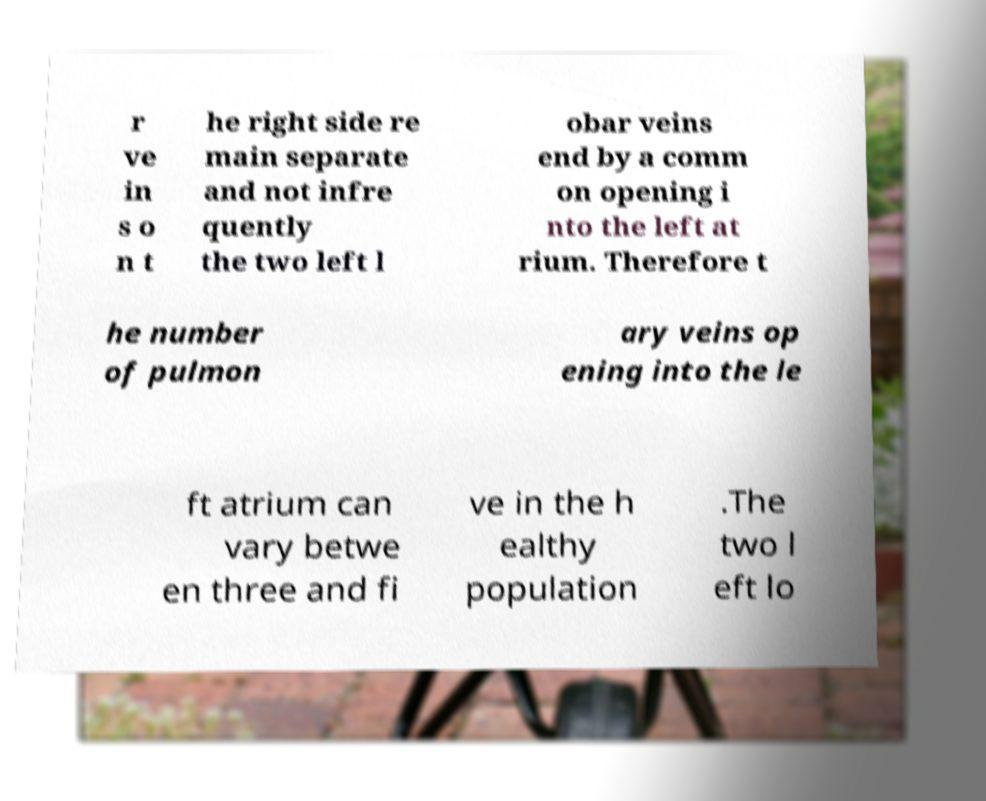Could you extract and type out the text from this image? r ve in s o n t he right side re main separate and not infre quently the two left l obar veins end by a comm on opening i nto the left at rium. Therefore t he number of pulmon ary veins op ening into the le ft atrium can vary betwe en three and fi ve in the h ealthy population .The two l eft lo 